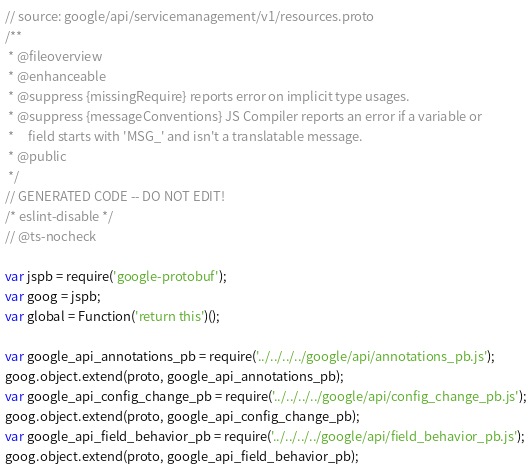<code> <loc_0><loc_0><loc_500><loc_500><_JavaScript_>// source: google/api/servicemanagement/v1/resources.proto
/**
 * @fileoverview
 * @enhanceable
 * @suppress {missingRequire} reports error on implicit type usages.
 * @suppress {messageConventions} JS Compiler reports an error if a variable or
 *     field starts with 'MSG_' and isn't a translatable message.
 * @public
 */
// GENERATED CODE -- DO NOT EDIT!
/* eslint-disable */
// @ts-nocheck

var jspb = require('google-protobuf');
var goog = jspb;
var global = Function('return this')();

var google_api_annotations_pb = require('../../../../google/api/annotations_pb.js');
goog.object.extend(proto, google_api_annotations_pb);
var google_api_config_change_pb = require('../../../../google/api/config_change_pb.js');
goog.object.extend(proto, google_api_config_change_pb);
var google_api_field_behavior_pb = require('../../../../google/api/field_behavior_pb.js');
goog.object.extend(proto, google_api_field_behavior_pb);</code> 